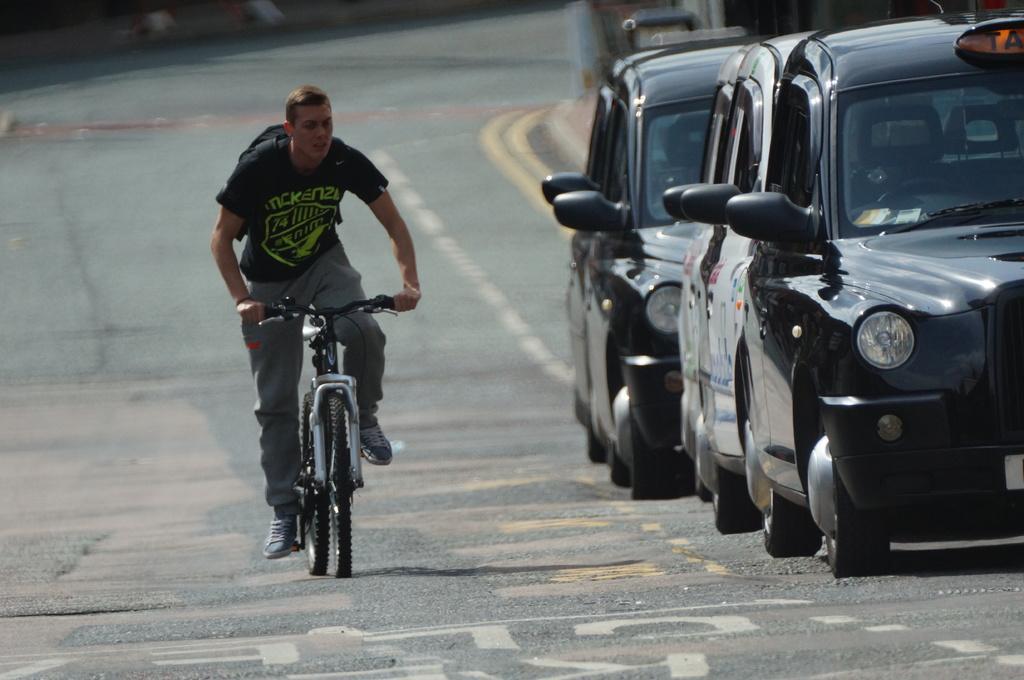How would you summarize this image in a sentence or two? In this image there is a person riding a bicycle on a road and there are cars, in the background it is blurred. 